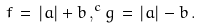Convert formula to latex. <formula><loc_0><loc_0><loc_500><loc_500>f \, = \, | a | + b \, , ^ { c } g \, = \, | a | - b \, .</formula> 